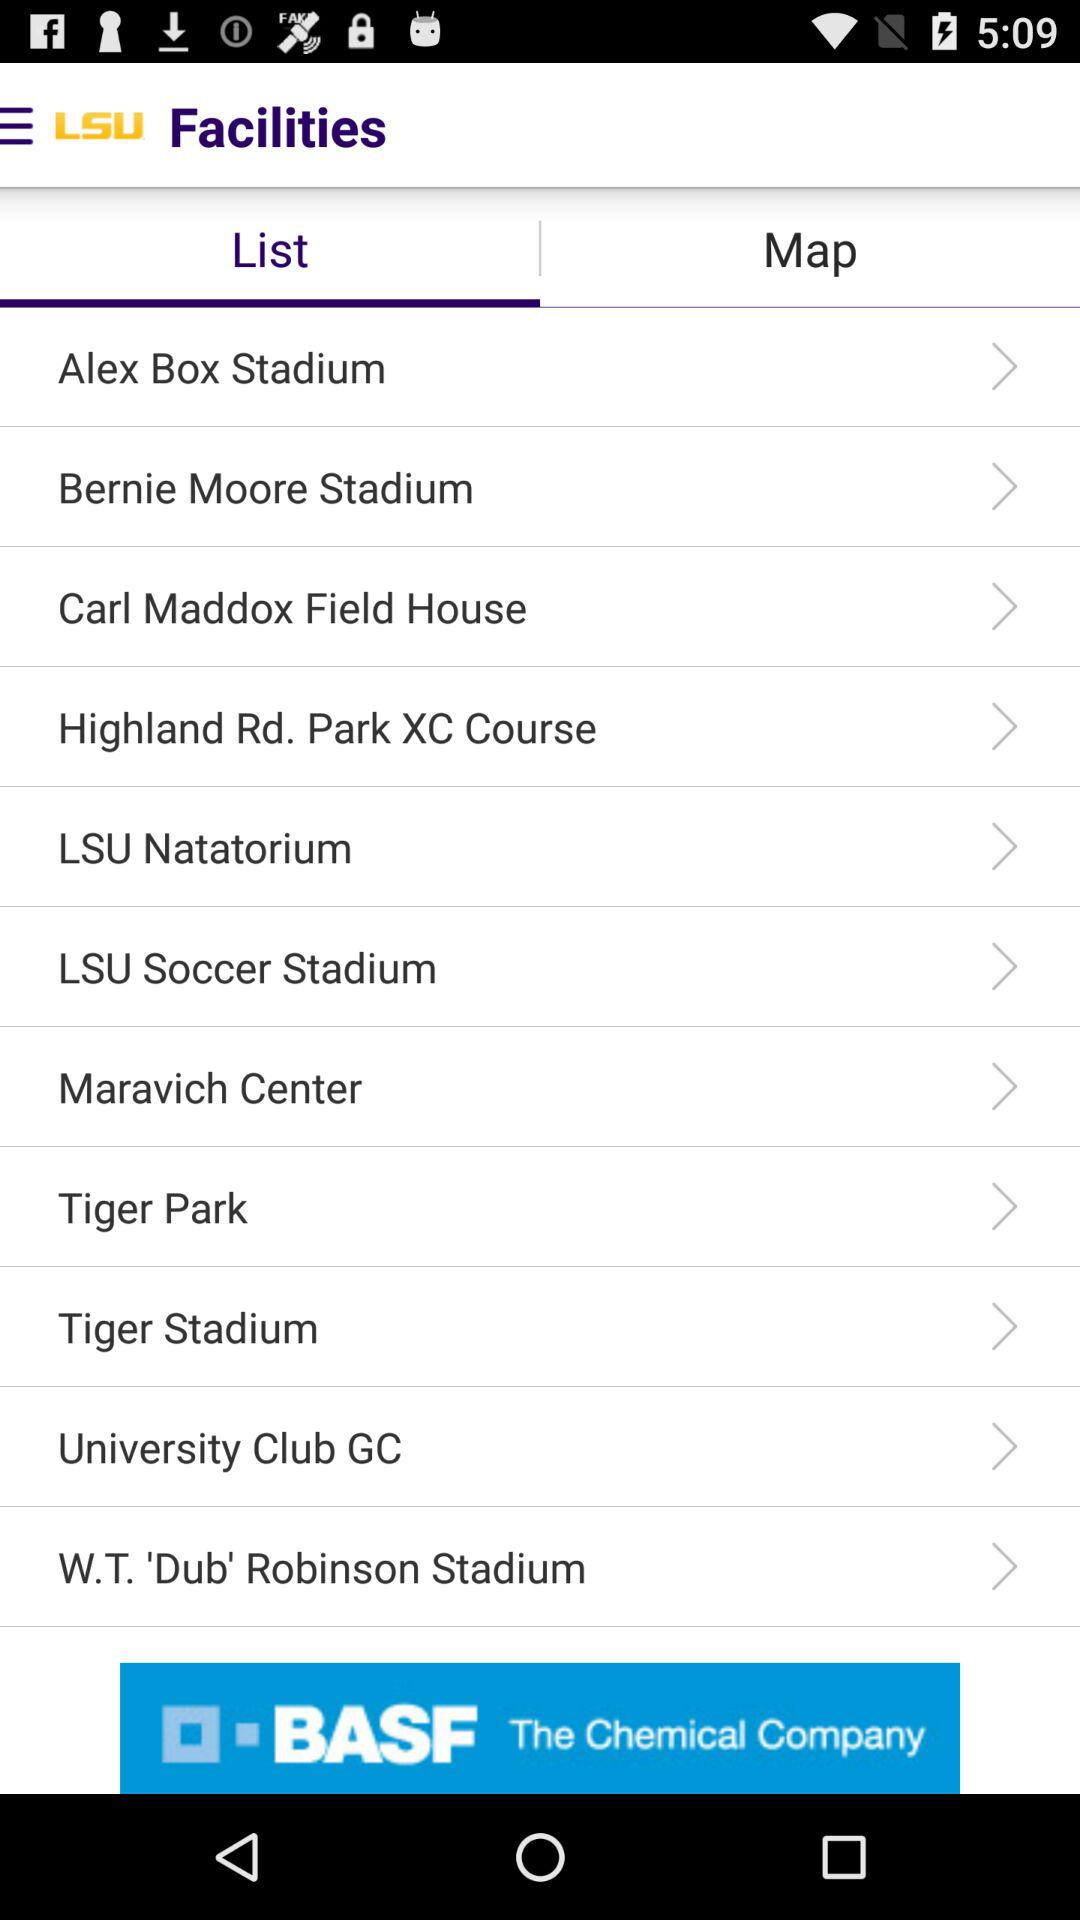Which tab is selected? The selected tab is "List". 